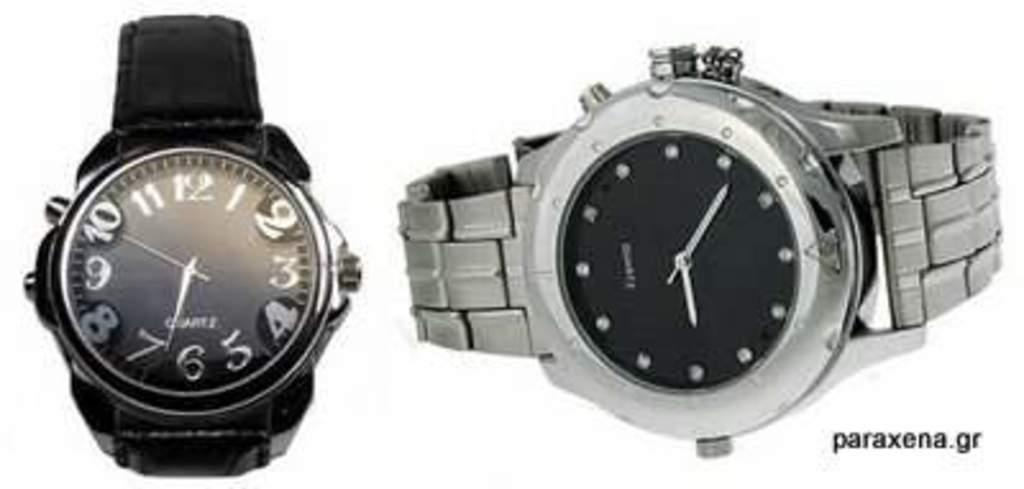<image>
Write a terse but informative summary of the picture. A silver watch being displayed made by Paraxena 